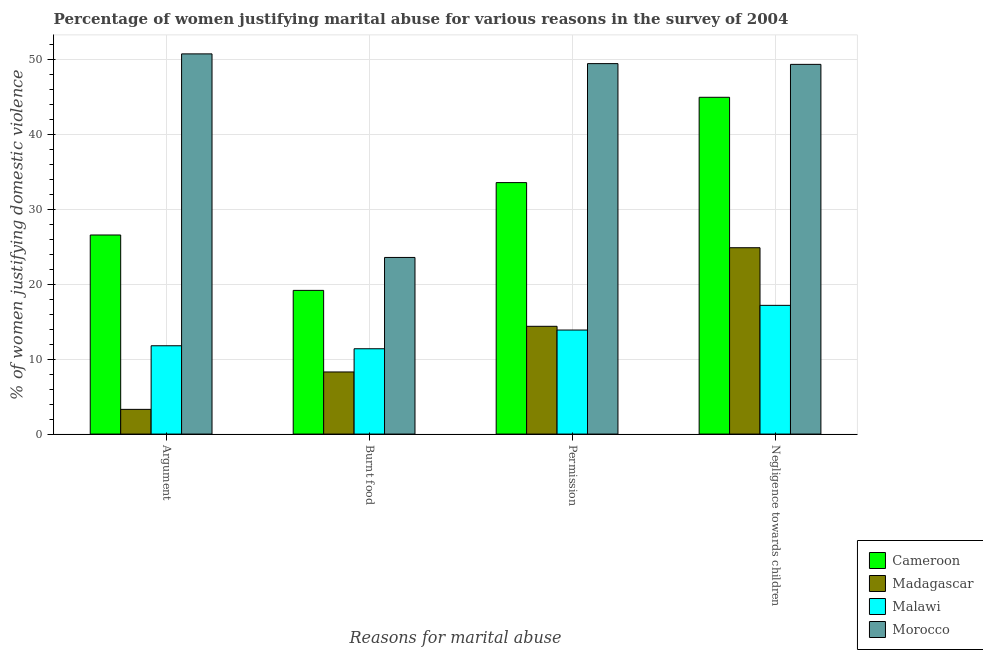Are the number of bars per tick equal to the number of legend labels?
Give a very brief answer. Yes. Are the number of bars on each tick of the X-axis equal?
Give a very brief answer. Yes. How many bars are there on the 1st tick from the right?
Your answer should be compact. 4. What is the label of the 4th group of bars from the left?
Make the answer very short. Negligence towards children. What is the percentage of women justifying abuse for going without permission in Morocco?
Your response must be concise. 49.5. Across all countries, what is the maximum percentage of women justifying abuse for showing negligence towards children?
Your response must be concise. 49.4. In which country was the percentage of women justifying abuse in the case of an argument maximum?
Your answer should be compact. Morocco. In which country was the percentage of women justifying abuse for going without permission minimum?
Give a very brief answer. Malawi. What is the total percentage of women justifying abuse in the case of an argument in the graph?
Provide a succinct answer. 92.5. What is the difference between the percentage of women justifying abuse for showing negligence towards children in Malawi and that in Madagascar?
Offer a very short reply. -7.7. What is the difference between the percentage of women justifying abuse in the case of an argument in Malawi and the percentage of women justifying abuse for going without permission in Cameroon?
Your answer should be compact. -21.8. What is the average percentage of women justifying abuse for showing negligence towards children per country?
Offer a terse response. 34.12. What is the difference between the percentage of women justifying abuse in the case of an argument and percentage of women justifying abuse for going without permission in Malawi?
Make the answer very short. -2.1. What is the ratio of the percentage of women justifying abuse for burning food in Malawi to that in Cameroon?
Provide a succinct answer. 0.59. Is the difference between the percentage of women justifying abuse in the case of an argument in Malawi and Cameroon greater than the difference between the percentage of women justifying abuse for going without permission in Malawi and Cameroon?
Ensure brevity in your answer.  Yes. What is the difference between the highest and the second highest percentage of women justifying abuse for burning food?
Provide a succinct answer. 4.4. What is the difference between the highest and the lowest percentage of women justifying abuse for showing negligence towards children?
Keep it short and to the point. 32.2. In how many countries, is the percentage of women justifying abuse for showing negligence towards children greater than the average percentage of women justifying abuse for showing negligence towards children taken over all countries?
Ensure brevity in your answer.  2. Is it the case that in every country, the sum of the percentage of women justifying abuse in the case of an argument and percentage of women justifying abuse for burning food is greater than the sum of percentage of women justifying abuse for going without permission and percentage of women justifying abuse for showing negligence towards children?
Make the answer very short. No. What does the 1st bar from the left in Burnt food represents?
Provide a succinct answer. Cameroon. What does the 4th bar from the right in Argument represents?
Keep it short and to the point. Cameroon. What is the difference between two consecutive major ticks on the Y-axis?
Make the answer very short. 10. Are the values on the major ticks of Y-axis written in scientific E-notation?
Your answer should be compact. No. What is the title of the graph?
Your answer should be compact. Percentage of women justifying marital abuse for various reasons in the survey of 2004. Does "Philippines" appear as one of the legend labels in the graph?
Provide a short and direct response. No. What is the label or title of the X-axis?
Your answer should be very brief. Reasons for marital abuse. What is the label or title of the Y-axis?
Offer a very short reply. % of women justifying domestic violence. What is the % of women justifying domestic violence of Cameroon in Argument?
Your answer should be compact. 26.6. What is the % of women justifying domestic violence of Morocco in Argument?
Provide a succinct answer. 50.8. What is the % of women justifying domestic violence of Cameroon in Burnt food?
Keep it short and to the point. 19.2. What is the % of women justifying domestic violence of Madagascar in Burnt food?
Offer a terse response. 8.3. What is the % of women justifying domestic violence in Morocco in Burnt food?
Offer a very short reply. 23.6. What is the % of women justifying domestic violence of Cameroon in Permission?
Provide a succinct answer. 33.6. What is the % of women justifying domestic violence of Malawi in Permission?
Ensure brevity in your answer.  13.9. What is the % of women justifying domestic violence in Morocco in Permission?
Make the answer very short. 49.5. What is the % of women justifying domestic violence of Cameroon in Negligence towards children?
Give a very brief answer. 45. What is the % of women justifying domestic violence in Madagascar in Negligence towards children?
Offer a very short reply. 24.9. What is the % of women justifying domestic violence in Morocco in Negligence towards children?
Your answer should be very brief. 49.4. Across all Reasons for marital abuse, what is the maximum % of women justifying domestic violence of Madagascar?
Your response must be concise. 24.9. Across all Reasons for marital abuse, what is the maximum % of women justifying domestic violence of Malawi?
Give a very brief answer. 17.2. Across all Reasons for marital abuse, what is the maximum % of women justifying domestic violence of Morocco?
Your answer should be compact. 50.8. Across all Reasons for marital abuse, what is the minimum % of women justifying domestic violence in Cameroon?
Your answer should be compact. 19.2. Across all Reasons for marital abuse, what is the minimum % of women justifying domestic violence in Madagascar?
Your answer should be compact. 3.3. Across all Reasons for marital abuse, what is the minimum % of women justifying domestic violence of Malawi?
Ensure brevity in your answer.  11.4. Across all Reasons for marital abuse, what is the minimum % of women justifying domestic violence in Morocco?
Provide a short and direct response. 23.6. What is the total % of women justifying domestic violence in Cameroon in the graph?
Offer a very short reply. 124.4. What is the total % of women justifying domestic violence of Madagascar in the graph?
Ensure brevity in your answer.  50.9. What is the total % of women justifying domestic violence in Malawi in the graph?
Provide a succinct answer. 54.3. What is the total % of women justifying domestic violence of Morocco in the graph?
Offer a very short reply. 173.3. What is the difference between the % of women justifying domestic violence in Madagascar in Argument and that in Burnt food?
Your response must be concise. -5. What is the difference between the % of women justifying domestic violence of Morocco in Argument and that in Burnt food?
Keep it short and to the point. 27.2. What is the difference between the % of women justifying domestic violence in Cameroon in Argument and that in Permission?
Your answer should be very brief. -7. What is the difference between the % of women justifying domestic violence in Morocco in Argument and that in Permission?
Offer a very short reply. 1.3. What is the difference between the % of women justifying domestic violence in Cameroon in Argument and that in Negligence towards children?
Your response must be concise. -18.4. What is the difference between the % of women justifying domestic violence of Madagascar in Argument and that in Negligence towards children?
Keep it short and to the point. -21.6. What is the difference between the % of women justifying domestic violence in Malawi in Argument and that in Negligence towards children?
Give a very brief answer. -5.4. What is the difference between the % of women justifying domestic violence of Cameroon in Burnt food and that in Permission?
Keep it short and to the point. -14.4. What is the difference between the % of women justifying domestic violence in Madagascar in Burnt food and that in Permission?
Provide a succinct answer. -6.1. What is the difference between the % of women justifying domestic violence in Malawi in Burnt food and that in Permission?
Offer a terse response. -2.5. What is the difference between the % of women justifying domestic violence in Morocco in Burnt food and that in Permission?
Keep it short and to the point. -25.9. What is the difference between the % of women justifying domestic violence of Cameroon in Burnt food and that in Negligence towards children?
Provide a succinct answer. -25.8. What is the difference between the % of women justifying domestic violence in Madagascar in Burnt food and that in Negligence towards children?
Make the answer very short. -16.6. What is the difference between the % of women justifying domestic violence of Malawi in Burnt food and that in Negligence towards children?
Ensure brevity in your answer.  -5.8. What is the difference between the % of women justifying domestic violence in Morocco in Burnt food and that in Negligence towards children?
Give a very brief answer. -25.8. What is the difference between the % of women justifying domestic violence of Cameroon in Permission and that in Negligence towards children?
Your answer should be very brief. -11.4. What is the difference between the % of women justifying domestic violence in Madagascar in Permission and that in Negligence towards children?
Give a very brief answer. -10.5. What is the difference between the % of women justifying domestic violence in Madagascar in Argument and the % of women justifying domestic violence in Morocco in Burnt food?
Offer a very short reply. -20.3. What is the difference between the % of women justifying domestic violence in Malawi in Argument and the % of women justifying domestic violence in Morocco in Burnt food?
Provide a short and direct response. -11.8. What is the difference between the % of women justifying domestic violence in Cameroon in Argument and the % of women justifying domestic violence in Madagascar in Permission?
Ensure brevity in your answer.  12.2. What is the difference between the % of women justifying domestic violence of Cameroon in Argument and the % of women justifying domestic violence of Malawi in Permission?
Provide a succinct answer. 12.7. What is the difference between the % of women justifying domestic violence in Cameroon in Argument and the % of women justifying domestic violence in Morocco in Permission?
Ensure brevity in your answer.  -22.9. What is the difference between the % of women justifying domestic violence of Madagascar in Argument and the % of women justifying domestic violence of Morocco in Permission?
Offer a very short reply. -46.2. What is the difference between the % of women justifying domestic violence of Malawi in Argument and the % of women justifying domestic violence of Morocco in Permission?
Ensure brevity in your answer.  -37.7. What is the difference between the % of women justifying domestic violence in Cameroon in Argument and the % of women justifying domestic violence in Madagascar in Negligence towards children?
Offer a terse response. 1.7. What is the difference between the % of women justifying domestic violence in Cameroon in Argument and the % of women justifying domestic violence in Morocco in Negligence towards children?
Offer a terse response. -22.8. What is the difference between the % of women justifying domestic violence of Madagascar in Argument and the % of women justifying domestic violence of Malawi in Negligence towards children?
Your response must be concise. -13.9. What is the difference between the % of women justifying domestic violence in Madagascar in Argument and the % of women justifying domestic violence in Morocco in Negligence towards children?
Ensure brevity in your answer.  -46.1. What is the difference between the % of women justifying domestic violence in Malawi in Argument and the % of women justifying domestic violence in Morocco in Negligence towards children?
Provide a short and direct response. -37.6. What is the difference between the % of women justifying domestic violence of Cameroon in Burnt food and the % of women justifying domestic violence of Madagascar in Permission?
Ensure brevity in your answer.  4.8. What is the difference between the % of women justifying domestic violence in Cameroon in Burnt food and the % of women justifying domestic violence in Malawi in Permission?
Keep it short and to the point. 5.3. What is the difference between the % of women justifying domestic violence of Cameroon in Burnt food and the % of women justifying domestic violence of Morocco in Permission?
Your response must be concise. -30.3. What is the difference between the % of women justifying domestic violence of Madagascar in Burnt food and the % of women justifying domestic violence of Morocco in Permission?
Provide a short and direct response. -41.2. What is the difference between the % of women justifying domestic violence in Malawi in Burnt food and the % of women justifying domestic violence in Morocco in Permission?
Your response must be concise. -38.1. What is the difference between the % of women justifying domestic violence of Cameroon in Burnt food and the % of women justifying domestic violence of Madagascar in Negligence towards children?
Make the answer very short. -5.7. What is the difference between the % of women justifying domestic violence in Cameroon in Burnt food and the % of women justifying domestic violence in Morocco in Negligence towards children?
Keep it short and to the point. -30.2. What is the difference between the % of women justifying domestic violence of Madagascar in Burnt food and the % of women justifying domestic violence of Malawi in Negligence towards children?
Keep it short and to the point. -8.9. What is the difference between the % of women justifying domestic violence of Madagascar in Burnt food and the % of women justifying domestic violence of Morocco in Negligence towards children?
Provide a short and direct response. -41.1. What is the difference between the % of women justifying domestic violence of Malawi in Burnt food and the % of women justifying domestic violence of Morocco in Negligence towards children?
Offer a very short reply. -38. What is the difference between the % of women justifying domestic violence of Cameroon in Permission and the % of women justifying domestic violence of Madagascar in Negligence towards children?
Your answer should be very brief. 8.7. What is the difference between the % of women justifying domestic violence in Cameroon in Permission and the % of women justifying domestic violence in Malawi in Negligence towards children?
Provide a short and direct response. 16.4. What is the difference between the % of women justifying domestic violence of Cameroon in Permission and the % of women justifying domestic violence of Morocco in Negligence towards children?
Your answer should be very brief. -15.8. What is the difference between the % of women justifying domestic violence of Madagascar in Permission and the % of women justifying domestic violence of Malawi in Negligence towards children?
Keep it short and to the point. -2.8. What is the difference between the % of women justifying domestic violence in Madagascar in Permission and the % of women justifying domestic violence in Morocco in Negligence towards children?
Offer a terse response. -35. What is the difference between the % of women justifying domestic violence in Malawi in Permission and the % of women justifying domestic violence in Morocco in Negligence towards children?
Offer a terse response. -35.5. What is the average % of women justifying domestic violence of Cameroon per Reasons for marital abuse?
Offer a very short reply. 31.1. What is the average % of women justifying domestic violence in Madagascar per Reasons for marital abuse?
Offer a very short reply. 12.72. What is the average % of women justifying domestic violence in Malawi per Reasons for marital abuse?
Give a very brief answer. 13.57. What is the average % of women justifying domestic violence of Morocco per Reasons for marital abuse?
Your answer should be very brief. 43.33. What is the difference between the % of women justifying domestic violence of Cameroon and % of women justifying domestic violence of Madagascar in Argument?
Ensure brevity in your answer.  23.3. What is the difference between the % of women justifying domestic violence of Cameroon and % of women justifying domestic violence of Malawi in Argument?
Make the answer very short. 14.8. What is the difference between the % of women justifying domestic violence of Cameroon and % of women justifying domestic violence of Morocco in Argument?
Make the answer very short. -24.2. What is the difference between the % of women justifying domestic violence in Madagascar and % of women justifying domestic violence in Malawi in Argument?
Ensure brevity in your answer.  -8.5. What is the difference between the % of women justifying domestic violence of Madagascar and % of women justifying domestic violence of Morocco in Argument?
Keep it short and to the point. -47.5. What is the difference between the % of women justifying domestic violence of Malawi and % of women justifying domestic violence of Morocco in Argument?
Ensure brevity in your answer.  -39. What is the difference between the % of women justifying domestic violence in Cameroon and % of women justifying domestic violence in Madagascar in Burnt food?
Make the answer very short. 10.9. What is the difference between the % of women justifying domestic violence in Madagascar and % of women justifying domestic violence in Morocco in Burnt food?
Make the answer very short. -15.3. What is the difference between the % of women justifying domestic violence in Malawi and % of women justifying domestic violence in Morocco in Burnt food?
Give a very brief answer. -12.2. What is the difference between the % of women justifying domestic violence of Cameroon and % of women justifying domestic violence of Malawi in Permission?
Your answer should be compact. 19.7. What is the difference between the % of women justifying domestic violence in Cameroon and % of women justifying domestic violence in Morocco in Permission?
Keep it short and to the point. -15.9. What is the difference between the % of women justifying domestic violence of Madagascar and % of women justifying domestic violence of Malawi in Permission?
Provide a succinct answer. 0.5. What is the difference between the % of women justifying domestic violence of Madagascar and % of women justifying domestic violence of Morocco in Permission?
Offer a very short reply. -35.1. What is the difference between the % of women justifying domestic violence in Malawi and % of women justifying domestic violence in Morocco in Permission?
Make the answer very short. -35.6. What is the difference between the % of women justifying domestic violence of Cameroon and % of women justifying domestic violence of Madagascar in Negligence towards children?
Your response must be concise. 20.1. What is the difference between the % of women justifying domestic violence in Cameroon and % of women justifying domestic violence in Malawi in Negligence towards children?
Offer a terse response. 27.8. What is the difference between the % of women justifying domestic violence of Cameroon and % of women justifying domestic violence of Morocco in Negligence towards children?
Your response must be concise. -4.4. What is the difference between the % of women justifying domestic violence of Madagascar and % of women justifying domestic violence of Morocco in Negligence towards children?
Make the answer very short. -24.5. What is the difference between the % of women justifying domestic violence of Malawi and % of women justifying domestic violence of Morocco in Negligence towards children?
Offer a very short reply. -32.2. What is the ratio of the % of women justifying domestic violence in Cameroon in Argument to that in Burnt food?
Your answer should be compact. 1.39. What is the ratio of the % of women justifying domestic violence of Madagascar in Argument to that in Burnt food?
Your answer should be compact. 0.4. What is the ratio of the % of women justifying domestic violence in Malawi in Argument to that in Burnt food?
Offer a very short reply. 1.04. What is the ratio of the % of women justifying domestic violence of Morocco in Argument to that in Burnt food?
Offer a terse response. 2.15. What is the ratio of the % of women justifying domestic violence of Cameroon in Argument to that in Permission?
Your response must be concise. 0.79. What is the ratio of the % of women justifying domestic violence of Madagascar in Argument to that in Permission?
Provide a short and direct response. 0.23. What is the ratio of the % of women justifying domestic violence in Malawi in Argument to that in Permission?
Your response must be concise. 0.85. What is the ratio of the % of women justifying domestic violence of Morocco in Argument to that in Permission?
Your response must be concise. 1.03. What is the ratio of the % of women justifying domestic violence in Cameroon in Argument to that in Negligence towards children?
Make the answer very short. 0.59. What is the ratio of the % of women justifying domestic violence in Madagascar in Argument to that in Negligence towards children?
Ensure brevity in your answer.  0.13. What is the ratio of the % of women justifying domestic violence of Malawi in Argument to that in Negligence towards children?
Provide a short and direct response. 0.69. What is the ratio of the % of women justifying domestic violence of Morocco in Argument to that in Negligence towards children?
Offer a very short reply. 1.03. What is the ratio of the % of women justifying domestic violence in Cameroon in Burnt food to that in Permission?
Provide a succinct answer. 0.57. What is the ratio of the % of women justifying domestic violence in Madagascar in Burnt food to that in Permission?
Keep it short and to the point. 0.58. What is the ratio of the % of women justifying domestic violence of Malawi in Burnt food to that in Permission?
Provide a succinct answer. 0.82. What is the ratio of the % of women justifying domestic violence in Morocco in Burnt food to that in Permission?
Your answer should be very brief. 0.48. What is the ratio of the % of women justifying domestic violence in Cameroon in Burnt food to that in Negligence towards children?
Your answer should be compact. 0.43. What is the ratio of the % of women justifying domestic violence of Malawi in Burnt food to that in Negligence towards children?
Ensure brevity in your answer.  0.66. What is the ratio of the % of women justifying domestic violence in Morocco in Burnt food to that in Negligence towards children?
Make the answer very short. 0.48. What is the ratio of the % of women justifying domestic violence in Cameroon in Permission to that in Negligence towards children?
Your response must be concise. 0.75. What is the ratio of the % of women justifying domestic violence in Madagascar in Permission to that in Negligence towards children?
Make the answer very short. 0.58. What is the ratio of the % of women justifying domestic violence in Malawi in Permission to that in Negligence towards children?
Offer a very short reply. 0.81. What is the difference between the highest and the second highest % of women justifying domestic violence of Madagascar?
Provide a short and direct response. 10.5. What is the difference between the highest and the second highest % of women justifying domestic violence in Malawi?
Give a very brief answer. 3.3. What is the difference between the highest and the lowest % of women justifying domestic violence in Cameroon?
Make the answer very short. 25.8. What is the difference between the highest and the lowest % of women justifying domestic violence of Madagascar?
Keep it short and to the point. 21.6. What is the difference between the highest and the lowest % of women justifying domestic violence of Malawi?
Provide a short and direct response. 5.8. What is the difference between the highest and the lowest % of women justifying domestic violence in Morocco?
Provide a short and direct response. 27.2. 